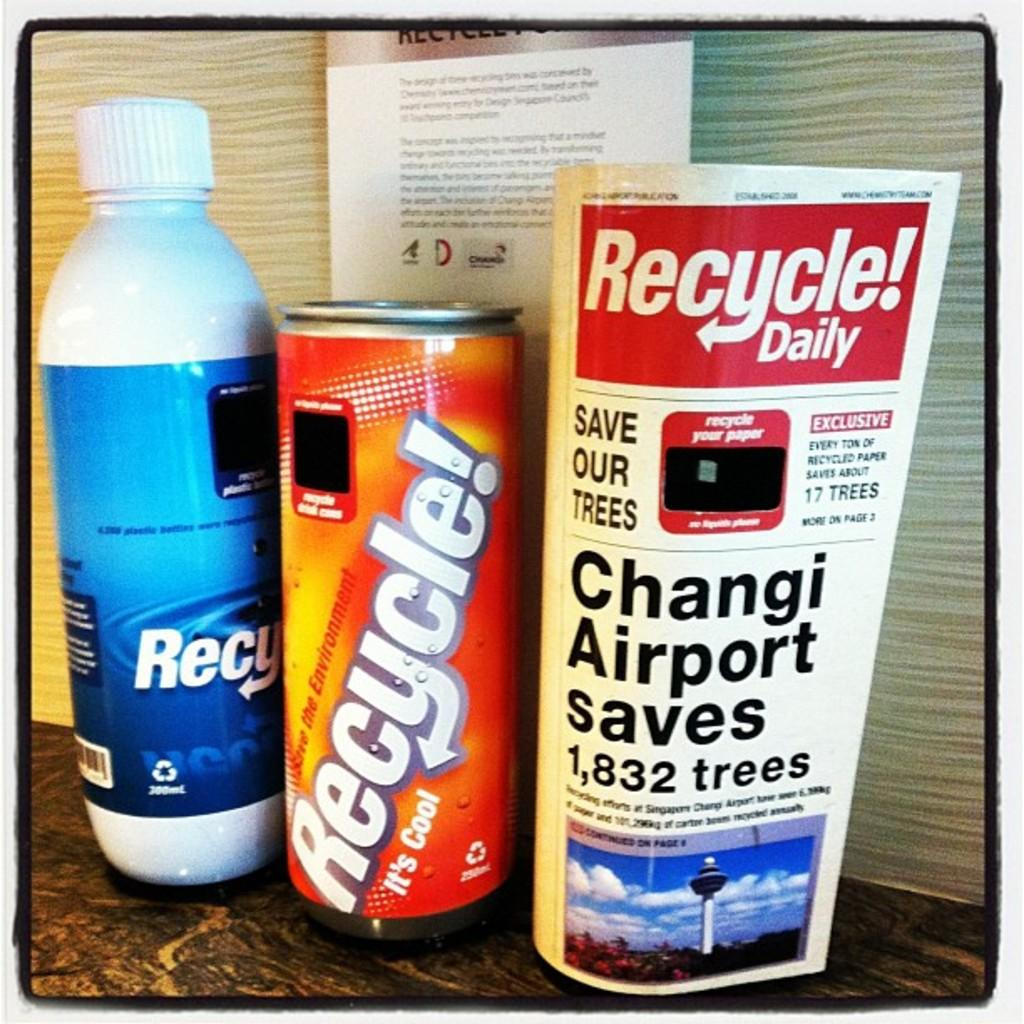<image>
Offer a succinct explanation of the picture presented. A bottle is in the middle and has the word recycle on it in white lettering. 